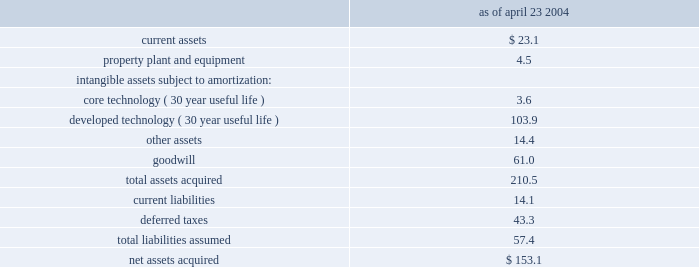Z i m m e r h o l d i n g s , i n c .
A n d s u b s i d i a r i e s 2 0 0 4 f o r m 1 0 - k notes to consolidated financial statements ( continued ) the company and implex had been operating since 2000 , the table summarizes the estimated fair values relating to the development and distribution of reconstructive of the assets acquired and liabilities assumed at the date of implant and trauma products incorporating trabecular metal the implex acquisition : ( in millions ) technology .
As ofthe merger agreement contains provisions for additional april 23 , 2004annual cash earn-out payments that are based on year-over- current assets $ 23.1year sales growth through 2006 of certain products that .
Estimates total earn-out payments , including payments core technology ( 30 year useful life ) 3.6 already made , to be in a range from $ 120 to $ 160 million .
Developed technology ( 30 year useful life ) 103.9 other assets 14.4these earn-out payments represent contingent consideration goodwill 61.0and , in accordance with sfas no .
141 and eitf 95-8 2018 2018accounting for contingent consideration paid to the total assets acquired 210.5 shareholders of an acquired enterprise in a purchase current liabilities 14.1 deferred taxes 43.3business combination 2019 2019 , are recorded as an additional cost of the transaction upon resolution of the contingency and total liabilities assumed 57.4 therefore increase goodwill .
Net assets acquired $ 153.1the implex acquisition was accounted for under the purchase method of accounting pursuant to sfas no .
141 .
Change in accounting principle accordingly , implex results of operations have been included in the company 2019s consolidated results of operations instruments are hand held devices used by orthopaedic subsequent to april 23 , 2004 , and its respective assets and surgeons during total joint replacement and other surgical liabilities have been recorded at their estimated fair values in procedures .
Effective january 1 , 2003 , instruments are the company 2019s consolidated statement of financial position as recognized as long-lived assets and are included in property , of april 23 , 2004 , with the excess purchase price being plant and equipment .
Undeployed instruments are carried at allocated to goodwill .
Pro forma financial information has not cost , net of allowances for obsolescence .
Instruments in the been included as the acquisition did not have a material field are carried at cost less accumulated depreciation .
Impact upon the company 2019s financial position , results of depreciation is computed using the straight-line method operations or cash flows .
Based on average estimated useful lives , determined the company completed the preliminary purchase price principally in reference to associated product life cycles , allocation in accordance with u.s .
Generally accepted primarily five years .
In accordance with sfas no .
144 , the accounting principles .
The process included interviews with company reviews instruments for impairment whenever management , review of the economic and competitive events or changes in circumstances indicate that the carrying environment and examination of assets including historical value of an asset may not be recoverable .
An impairment loss performance and future prospects .
The preliminary purchase would be recognized when estimated future cash flows price allocation was based on information currently available relating to the asset are less than its carrying amount .
To the company , and expectations and assumptions deemed depreciation of instruments is recognized as selling , general reasonable by the company 2019s management .
No assurance can and administrative expense , consistent with the classification be given , however , that the underlying assumptions used to of instrument cost in periods prior to january 1 , 2003 .
Estimate expected technology based product revenues , prior to january 1 , 2003 , undeployed instruments were development costs or profitability , or the events associated carried as a prepaid expense at cost , net of allowances for with such technology , will occur as projected .
The final obsolescence ( $ 54.8 million , net , at december 31 , 2002 ) , and purchase price allocation may vary from the preliminary recognized in selling , general and administrative expense in purchase price allocation .
The final valuation and associated the year in which the instruments were placed into service .
Purchase price allocation is expected to be completed as the new method of accounting for instruments was adopted soon as possible , but no later than one year from the date of to recognize the cost of these important assets of the acquisition .
To the extent that the estimates need to be company 2019s business within the consolidated balance sheet adjusted , the company will do so .
And meaningfully allocate the cost of these assets over the periods benefited , typically five years .
The effect of the change during the year ended december 31 , 2003 was to increase earnings before cumulative effect of change in accounting principle by $ 26.8 million ( $ 17.8 million net of tax ) , or $ 0.08 per diluted share .
The cumulative effect adjustment of $ 55.1 million ( net of income taxes of $ 34.0 million ) to retroactively apply the .
What is the percent difference in total assets acquired and net assets acquired? 
Computations: ((210.5 - 153.1) / 153.1)
Answer: 0.37492. 